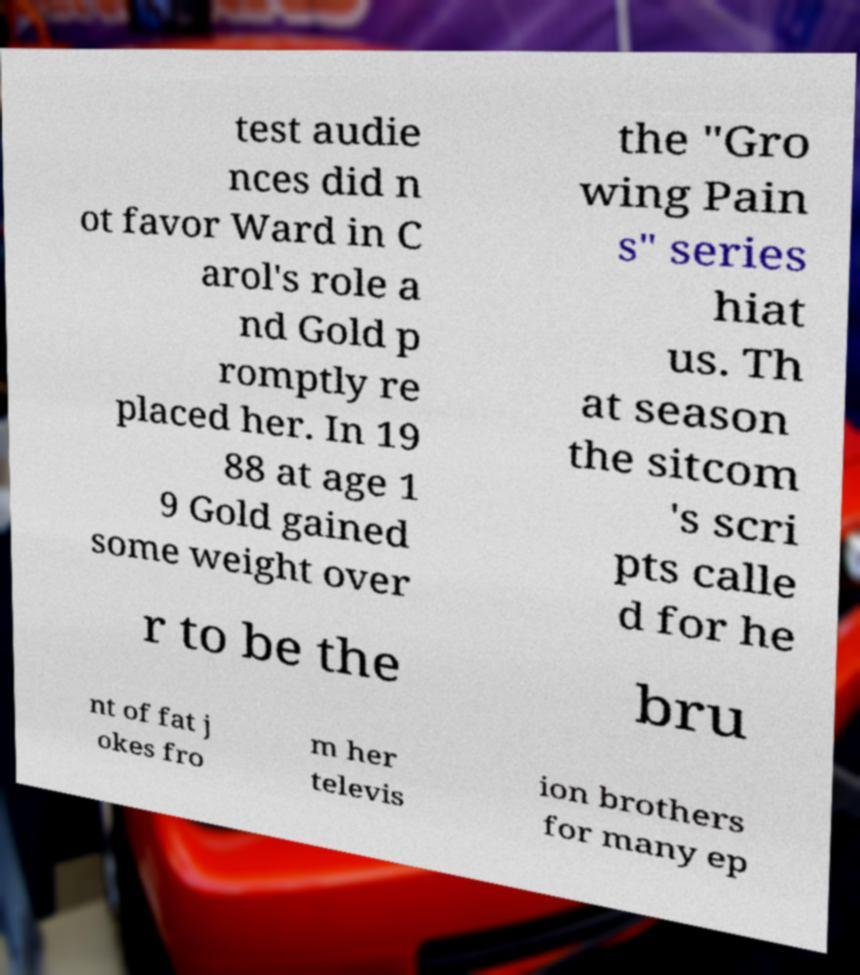Please identify and transcribe the text found in this image. test audie nces did n ot favor Ward in C arol's role a nd Gold p romptly re placed her. In 19 88 at age 1 9 Gold gained some weight over the "Gro wing Pain s" series hiat us. Th at season the sitcom 's scri pts calle d for he r to be the bru nt of fat j okes fro m her televis ion brothers for many ep 